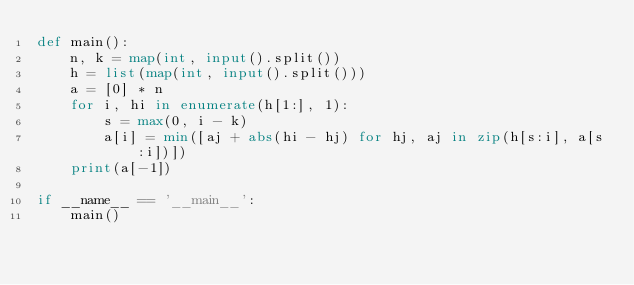<code> <loc_0><loc_0><loc_500><loc_500><_Python_>def main():
    n, k = map(int, input().split())
    h = list(map(int, input().split()))
    a = [0] * n
    for i, hi in enumerate(h[1:], 1):
        s = max(0, i - k)
        a[i] = min([aj + abs(hi - hj) for hj, aj in zip(h[s:i], a[s:i])])
    print(a[-1])

if __name__ == '__main__':
    main()
</code> 